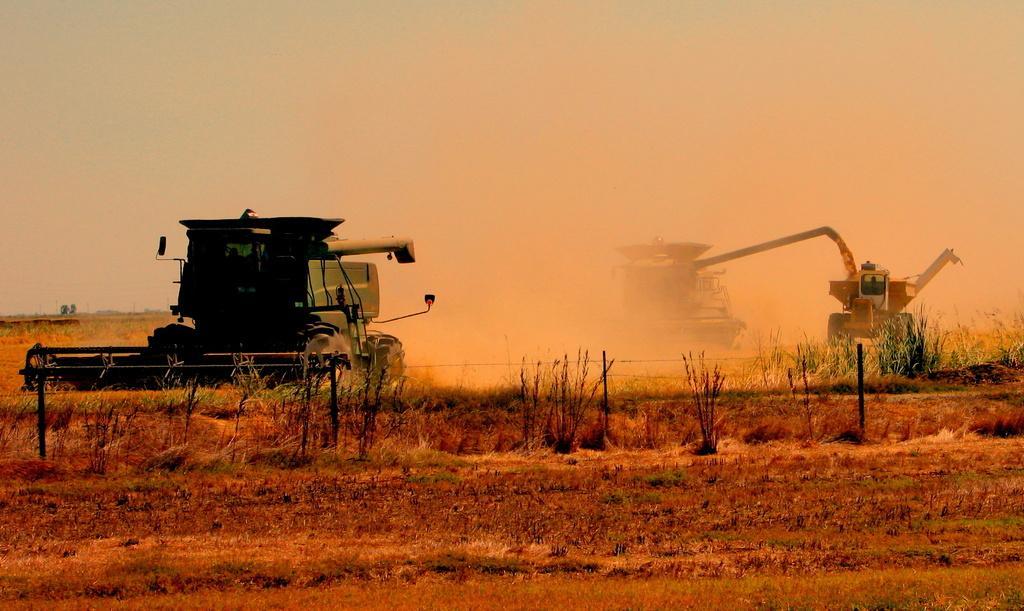Could you give a brief overview of what you see in this image? In the center of the image we can see bulldozers. At the bottom there is grass. In the background there is sky. 